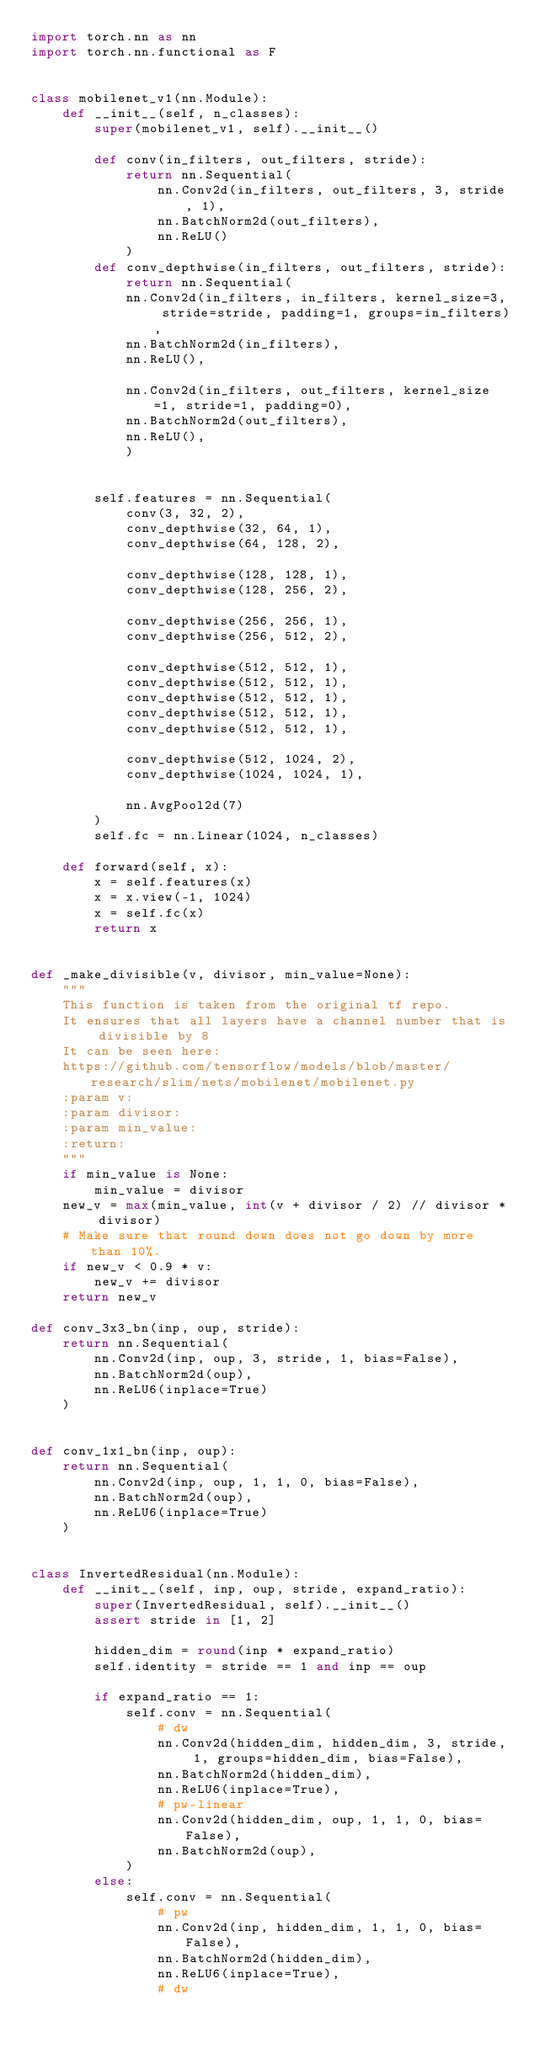Convert code to text. <code><loc_0><loc_0><loc_500><loc_500><_Python_>import torch.nn as nn
import torch.nn.functional as F


class mobilenet_v1(nn.Module):
    def __init__(self, n_classes):
        super(mobilenet_v1, self).__init__()

        def conv(in_filters, out_filters, stride):
            return nn.Sequential(
                nn.Conv2d(in_filters, out_filters, 3, stride, 1),
                nn.BatchNorm2d(out_filters),
                nn.ReLU()
            )
        def conv_depthwise(in_filters, out_filters, stride):
            return nn.Sequential(
            nn.Conv2d(in_filters, in_filters, kernel_size=3, stride=stride, padding=1, groups=in_filters),
            nn.BatchNorm2d(in_filters),
            nn.ReLU(),

            nn.Conv2d(in_filters, out_filters, kernel_size=1, stride=1, padding=0),
            nn.BatchNorm2d(out_filters),
            nn.ReLU(),
            )


        self.features = nn.Sequential(
            conv(3, 32, 2),
            conv_depthwise(32, 64, 1),
            conv_depthwise(64, 128, 2),

            conv_depthwise(128, 128, 1),
            conv_depthwise(128, 256, 2),

            conv_depthwise(256, 256, 1),
            conv_depthwise(256, 512, 2),

            conv_depthwise(512, 512, 1),
            conv_depthwise(512, 512, 1),
            conv_depthwise(512, 512, 1),
            conv_depthwise(512, 512, 1),
            conv_depthwise(512, 512, 1),

            conv_depthwise(512, 1024, 2),
            conv_depthwise(1024, 1024, 1),

            nn.AvgPool2d(7)
        )
        self.fc = nn.Linear(1024, n_classes)

    def forward(self, x):
        x = self.features(x)
        x = x.view(-1, 1024)
        x = self.fc(x)
        return x


def _make_divisible(v, divisor, min_value=None):
    """
    This function is taken from the original tf repo.
    It ensures that all layers have a channel number that is divisible by 8
    It can be seen here:
    https://github.com/tensorflow/models/blob/master/research/slim/nets/mobilenet/mobilenet.py
    :param v:
    :param divisor:
    :param min_value:
    :return:
    """
    if min_value is None:
        min_value = divisor
    new_v = max(min_value, int(v + divisor / 2) // divisor * divisor)
    # Make sure that round down does not go down by more than 10%.
    if new_v < 0.9 * v:
        new_v += divisor
    return new_v

def conv_3x3_bn(inp, oup, stride):
    return nn.Sequential(
        nn.Conv2d(inp, oup, 3, stride, 1, bias=False),
        nn.BatchNorm2d(oup),
        nn.ReLU6(inplace=True)
    )


def conv_1x1_bn(inp, oup):
    return nn.Sequential(
        nn.Conv2d(inp, oup, 1, 1, 0, bias=False),
        nn.BatchNorm2d(oup),
        nn.ReLU6(inplace=True)
    )


class InvertedResidual(nn.Module):
    def __init__(self, inp, oup, stride, expand_ratio):
        super(InvertedResidual, self).__init__()
        assert stride in [1, 2]

        hidden_dim = round(inp * expand_ratio)
        self.identity = stride == 1 and inp == oup

        if expand_ratio == 1:
            self.conv = nn.Sequential(
                # dw
                nn.Conv2d(hidden_dim, hidden_dim, 3, stride, 1, groups=hidden_dim, bias=False),
                nn.BatchNorm2d(hidden_dim),
                nn.ReLU6(inplace=True),
                # pw-linear
                nn.Conv2d(hidden_dim, oup, 1, 1, 0, bias=False),
                nn.BatchNorm2d(oup),
            )
        else:
            self.conv = nn.Sequential(
                # pw
                nn.Conv2d(inp, hidden_dim, 1, 1, 0, bias=False),
                nn.BatchNorm2d(hidden_dim),
                nn.ReLU6(inplace=True),
                # dw</code> 